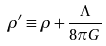<formula> <loc_0><loc_0><loc_500><loc_500>\rho ^ { \prime } \equiv \rho + { \frac { \Lambda } { 8 \pi G } }</formula> 